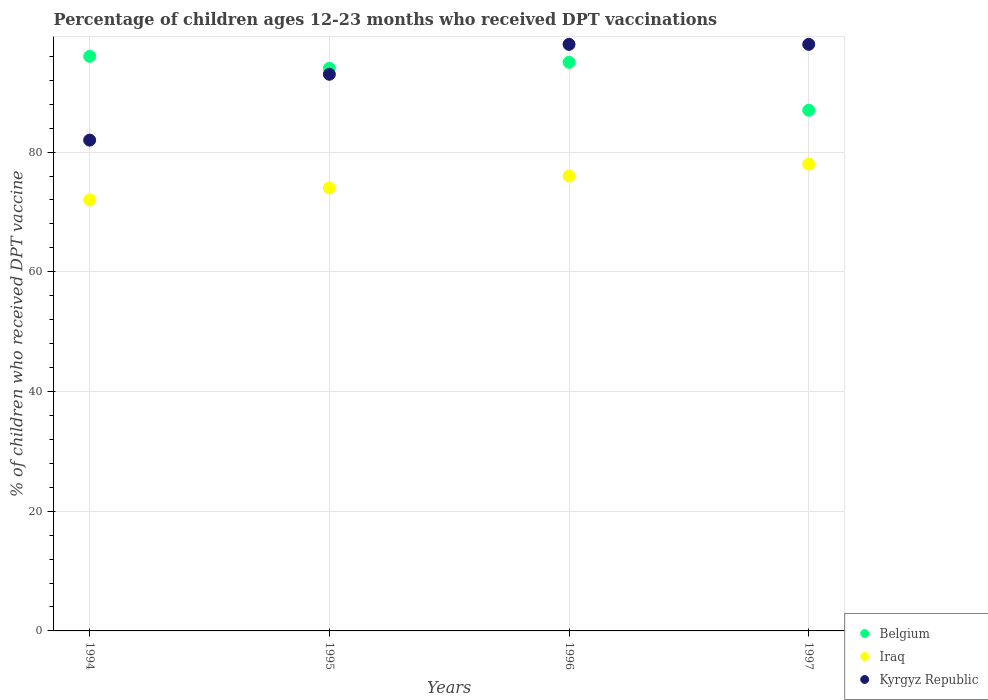How many different coloured dotlines are there?
Give a very brief answer. 3. What is the percentage of children who received DPT vaccination in Belgium in 1997?
Provide a short and direct response. 87. Across all years, what is the maximum percentage of children who received DPT vaccination in Belgium?
Make the answer very short. 96. Across all years, what is the minimum percentage of children who received DPT vaccination in Kyrgyz Republic?
Give a very brief answer. 82. In which year was the percentage of children who received DPT vaccination in Kyrgyz Republic maximum?
Give a very brief answer. 1996. What is the total percentage of children who received DPT vaccination in Belgium in the graph?
Your answer should be very brief. 372. What is the difference between the percentage of children who received DPT vaccination in Belgium in 1996 and that in 1997?
Give a very brief answer. 8. What is the average percentage of children who received DPT vaccination in Iraq per year?
Ensure brevity in your answer.  75. In the year 1997, what is the difference between the percentage of children who received DPT vaccination in Iraq and percentage of children who received DPT vaccination in Kyrgyz Republic?
Provide a short and direct response. -20. In how many years, is the percentage of children who received DPT vaccination in Belgium greater than 12 %?
Offer a terse response. 4. What is the ratio of the percentage of children who received DPT vaccination in Kyrgyz Republic in 1994 to that in 1996?
Offer a very short reply. 0.84. Is the difference between the percentage of children who received DPT vaccination in Iraq in 1994 and 1995 greater than the difference between the percentage of children who received DPT vaccination in Kyrgyz Republic in 1994 and 1995?
Make the answer very short. Yes. What is the difference between the highest and the second highest percentage of children who received DPT vaccination in Kyrgyz Republic?
Offer a terse response. 0. What is the difference between the highest and the lowest percentage of children who received DPT vaccination in Belgium?
Offer a terse response. 9. Does the percentage of children who received DPT vaccination in Kyrgyz Republic monotonically increase over the years?
Your response must be concise. No. Is the percentage of children who received DPT vaccination in Kyrgyz Republic strictly less than the percentage of children who received DPT vaccination in Belgium over the years?
Your answer should be very brief. No. Does the graph contain grids?
Your answer should be very brief. Yes. Where does the legend appear in the graph?
Your answer should be compact. Bottom right. What is the title of the graph?
Your response must be concise. Percentage of children ages 12-23 months who received DPT vaccinations. What is the label or title of the X-axis?
Ensure brevity in your answer.  Years. What is the label or title of the Y-axis?
Your answer should be very brief. % of children who received DPT vaccine. What is the % of children who received DPT vaccine of Belgium in 1994?
Ensure brevity in your answer.  96. What is the % of children who received DPT vaccine in Kyrgyz Republic in 1994?
Your answer should be compact. 82. What is the % of children who received DPT vaccine in Belgium in 1995?
Make the answer very short. 94. What is the % of children who received DPT vaccine of Iraq in 1995?
Your answer should be very brief. 74. What is the % of children who received DPT vaccine of Kyrgyz Republic in 1995?
Offer a very short reply. 93. What is the % of children who received DPT vaccine of Belgium in 1996?
Keep it short and to the point. 95. What is the % of children who received DPT vaccine of Iraq in 1996?
Ensure brevity in your answer.  76. What is the % of children who received DPT vaccine in Belgium in 1997?
Give a very brief answer. 87. Across all years, what is the maximum % of children who received DPT vaccine of Belgium?
Give a very brief answer. 96. Across all years, what is the maximum % of children who received DPT vaccine of Iraq?
Your answer should be compact. 78. Across all years, what is the minimum % of children who received DPT vaccine in Belgium?
Your response must be concise. 87. What is the total % of children who received DPT vaccine in Belgium in the graph?
Your answer should be very brief. 372. What is the total % of children who received DPT vaccine in Iraq in the graph?
Provide a succinct answer. 300. What is the total % of children who received DPT vaccine of Kyrgyz Republic in the graph?
Provide a succinct answer. 371. What is the difference between the % of children who received DPT vaccine of Iraq in 1994 and that in 1995?
Provide a short and direct response. -2. What is the difference between the % of children who received DPT vaccine in Kyrgyz Republic in 1994 and that in 1995?
Provide a short and direct response. -11. What is the difference between the % of children who received DPT vaccine of Belgium in 1994 and that in 1996?
Give a very brief answer. 1. What is the difference between the % of children who received DPT vaccine of Kyrgyz Republic in 1994 and that in 1996?
Provide a succinct answer. -16. What is the difference between the % of children who received DPT vaccine of Belgium in 1994 and that in 1997?
Keep it short and to the point. 9. What is the difference between the % of children who received DPT vaccine of Kyrgyz Republic in 1994 and that in 1997?
Give a very brief answer. -16. What is the difference between the % of children who received DPT vaccine of Iraq in 1995 and that in 1996?
Give a very brief answer. -2. What is the difference between the % of children who received DPT vaccine in Iraq in 1995 and that in 1997?
Provide a short and direct response. -4. What is the difference between the % of children who received DPT vaccine of Iraq in 1996 and that in 1997?
Your response must be concise. -2. What is the difference between the % of children who received DPT vaccine in Belgium in 1994 and the % of children who received DPT vaccine in Kyrgyz Republic in 1995?
Your response must be concise. 3. What is the difference between the % of children who received DPT vaccine of Iraq in 1994 and the % of children who received DPT vaccine of Kyrgyz Republic in 1995?
Your response must be concise. -21. What is the difference between the % of children who received DPT vaccine in Belgium in 1994 and the % of children who received DPT vaccine in Iraq in 1996?
Make the answer very short. 20. What is the difference between the % of children who received DPT vaccine of Belgium in 1994 and the % of children who received DPT vaccine of Kyrgyz Republic in 1997?
Provide a short and direct response. -2. What is the difference between the % of children who received DPT vaccine in Iraq in 1994 and the % of children who received DPT vaccine in Kyrgyz Republic in 1997?
Provide a succinct answer. -26. What is the difference between the % of children who received DPT vaccine of Belgium in 1995 and the % of children who received DPT vaccine of Iraq in 1996?
Make the answer very short. 18. What is the difference between the % of children who received DPT vaccine of Iraq in 1995 and the % of children who received DPT vaccine of Kyrgyz Republic in 1996?
Your response must be concise. -24. What is the difference between the % of children who received DPT vaccine of Belgium in 1995 and the % of children who received DPT vaccine of Kyrgyz Republic in 1997?
Provide a succinct answer. -4. What is the difference between the % of children who received DPT vaccine in Belgium in 1996 and the % of children who received DPT vaccine in Kyrgyz Republic in 1997?
Keep it short and to the point. -3. What is the difference between the % of children who received DPT vaccine of Iraq in 1996 and the % of children who received DPT vaccine of Kyrgyz Republic in 1997?
Offer a terse response. -22. What is the average % of children who received DPT vaccine of Belgium per year?
Your answer should be very brief. 93. What is the average % of children who received DPT vaccine in Iraq per year?
Offer a very short reply. 75. What is the average % of children who received DPT vaccine of Kyrgyz Republic per year?
Your answer should be compact. 92.75. In the year 1994, what is the difference between the % of children who received DPT vaccine in Iraq and % of children who received DPT vaccine in Kyrgyz Republic?
Your response must be concise. -10. In the year 1997, what is the difference between the % of children who received DPT vaccine in Belgium and % of children who received DPT vaccine in Kyrgyz Republic?
Make the answer very short. -11. In the year 1997, what is the difference between the % of children who received DPT vaccine in Iraq and % of children who received DPT vaccine in Kyrgyz Republic?
Provide a short and direct response. -20. What is the ratio of the % of children who received DPT vaccine of Belgium in 1994 to that in 1995?
Keep it short and to the point. 1.02. What is the ratio of the % of children who received DPT vaccine of Iraq in 1994 to that in 1995?
Your answer should be compact. 0.97. What is the ratio of the % of children who received DPT vaccine of Kyrgyz Republic in 1994 to that in 1995?
Your answer should be very brief. 0.88. What is the ratio of the % of children who received DPT vaccine in Belgium in 1994 to that in 1996?
Offer a terse response. 1.01. What is the ratio of the % of children who received DPT vaccine in Kyrgyz Republic in 1994 to that in 1996?
Provide a succinct answer. 0.84. What is the ratio of the % of children who received DPT vaccine of Belgium in 1994 to that in 1997?
Offer a very short reply. 1.1. What is the ratio of the % of children who received DPT vaccine of Kyrgyz Republic in 1994 to that in 1997?
Give a very brief answer. 0.84. What is the ratio of the % of children who received DPT vaccine in Iraq in 1995 to that in 1996?
Give a very brief answer. 0.97. What is the ratio of the % of children who received DPT vaccine of Kyrgyz Republic in 1995 to that in 1996?
Keep it short and to the point. 0.95. What is the ratio of the % of children who received DPT vaccine of Belgium in 1995 to that in 1997?
Offer a very short reply. 1.08. What is the ratio of the % of children who received DPT vaccine of Iraq in 1995 to that in 1997?
Keep it short and to the point. 0.95. What is the ratio of the % of children who received DPT vaccine in Kyrgyz Republic in 1995 to that in 1997?
Make the answer very short. 0.95. What is the ratio of the % of children who received DPT vaccine in Belgium in 1996 to that in 1997?
Ensure brevity in your answer.  1.09. What is the ratio of the % of children who received DPT vaccine in Iraq in 1996 to that in 1997?
Provide a short and direct response. 0.97. What is the difference between the highest and the second highest % of children who received DPT vaccine in Belgium?
Your answer should be very brief. 1. What is the difference between the highest and the lowest % of children who received DPT vaccine of Belgium?
Ensure brevity in your answer.  9. 